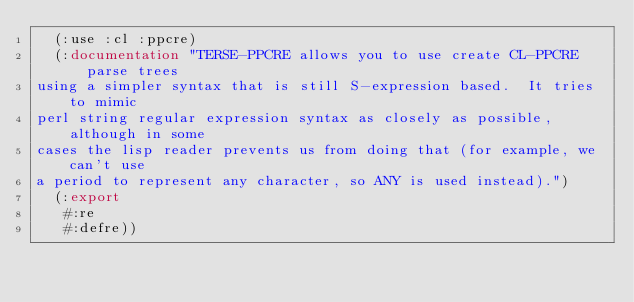Convert code to text. <code><loc_0><loc_0><loc_500><loc_500><_Lisp_>  (:use :cl :ppcre)
  (:documentation "TERSE-PPCRE allows you to use create CL-PPCRE parse trees
using a simpler syntax that is still S-expression based.  It tries to mimic
perl string regular expression syntax as closely as possible, although in some
cases the lisp reader prevents us from doing that (for example, we can't use
a period to represent any character, so ANY is used instead).")
  (:export
   #:re
   #:defre))



</code> 